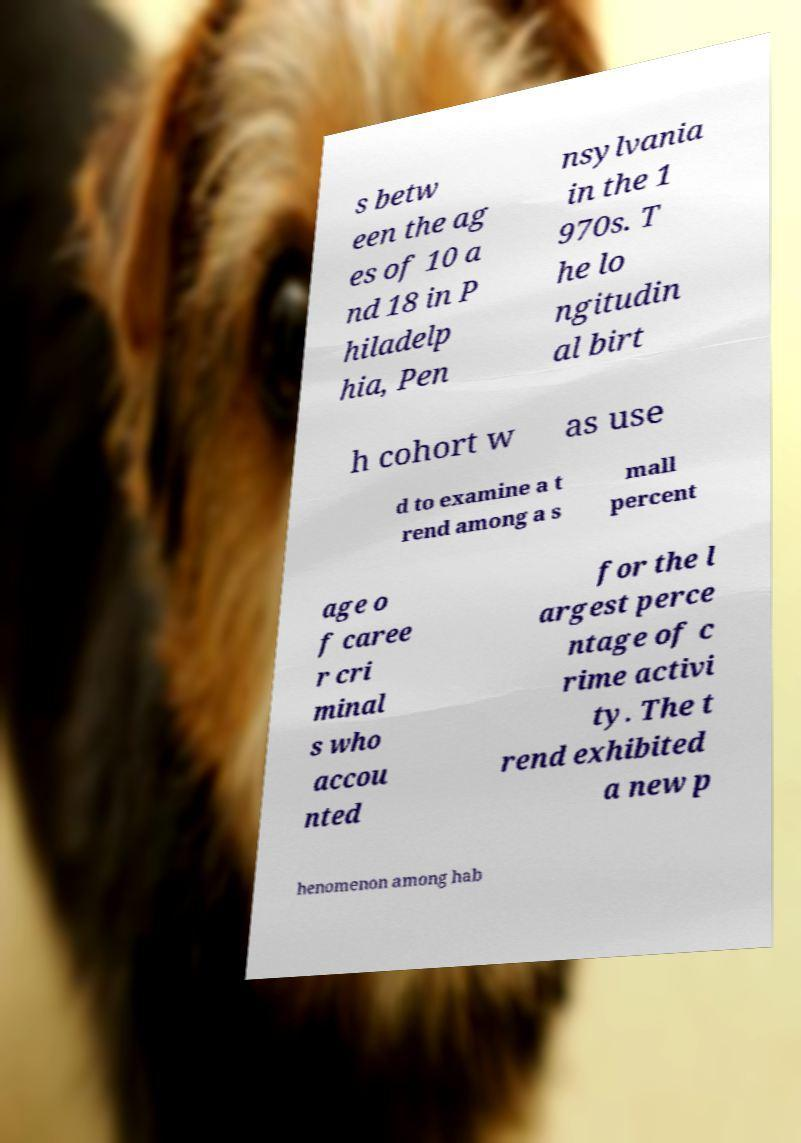Please read and relay the text visible in this image. What does it say? s betw een the ag es of 10 a nd 18 in P hiladelp hia, Pen nsylvania in the 1 970s. T he lo ngitudin al birt h cohort w as use d to examine a t rend among a s mall percent age o f caree r cri minal s who accou nted for the l argest perce ntage of c rime activi ty. The t rend exhibited a new p henomenon among hab 